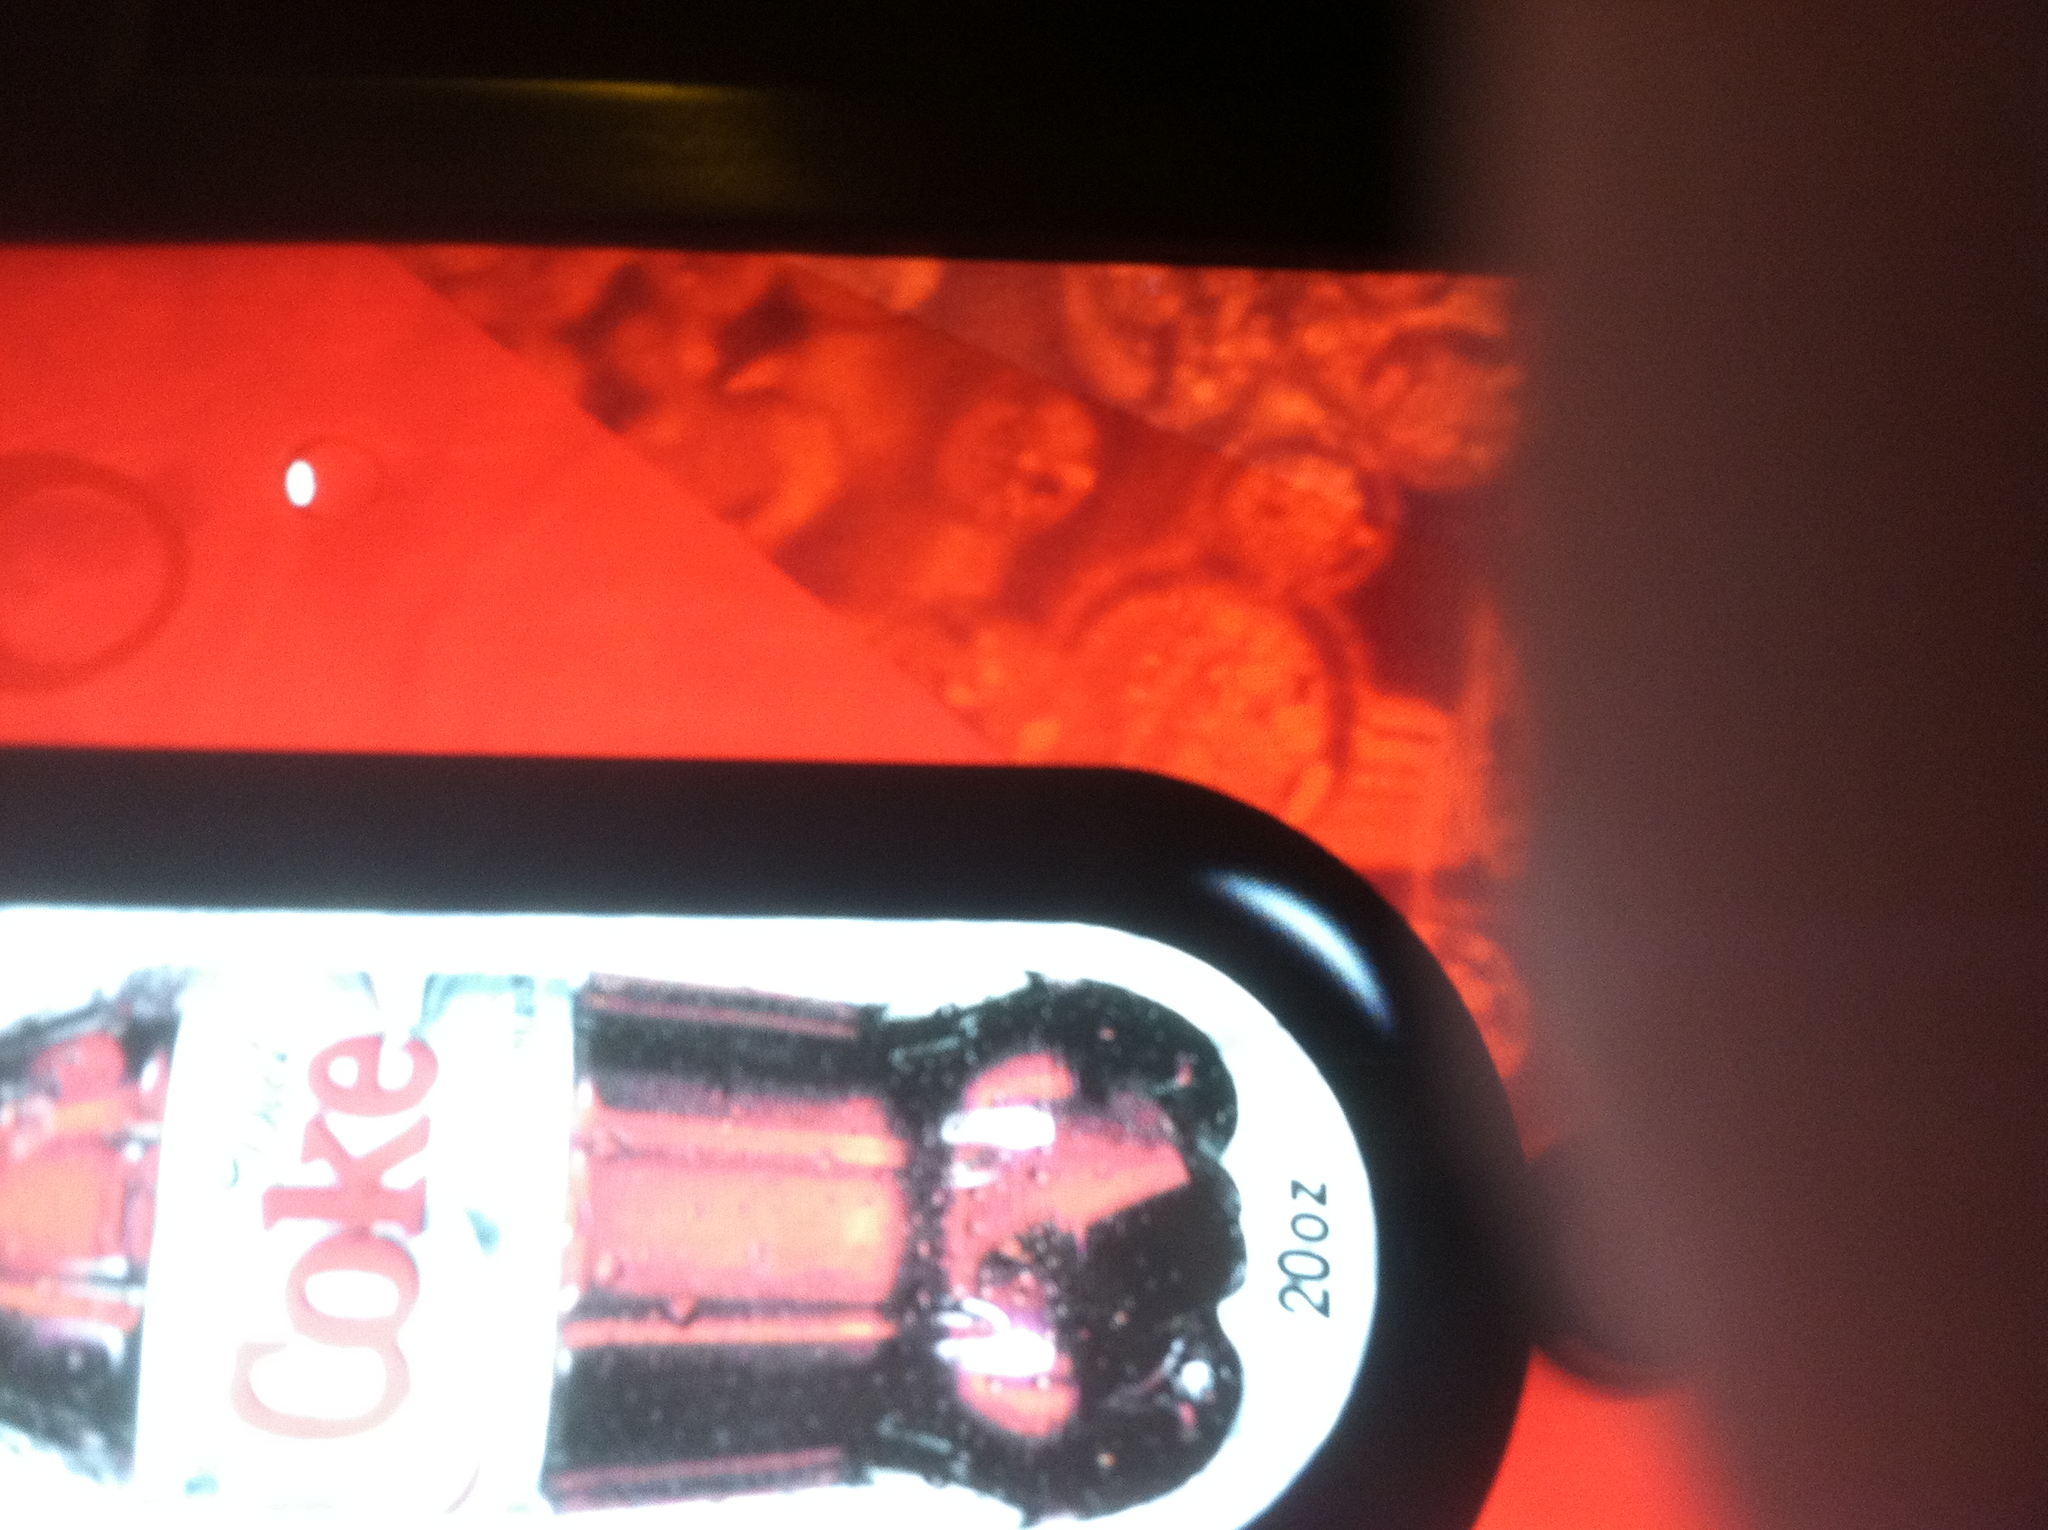How would you explain the significance of this image to someone from another planet? This image represents a popular beverage on our planet known as Diet Coke, recognized for its distinctive red and silver packaging. It is a low-calorie variant of a classic soda, Coca-Cola, which is enjoyed by people worldwide. The vending machine it is dispensed from symbolizes modern convenience and the universal appeal of soft drinks in human culture. Could the design elements in this image have any symbolic meaning? Yes, the design elements likely have symbolic meaning. The red color represents energy, passion, and excitement, which aligns with the brand’s intention to evoke a lively and enjoyable drinking experience. The silver label of Diet Coke suggests a sleek, modern, and health-conscious choice within the broader Coca-Cola product line. 